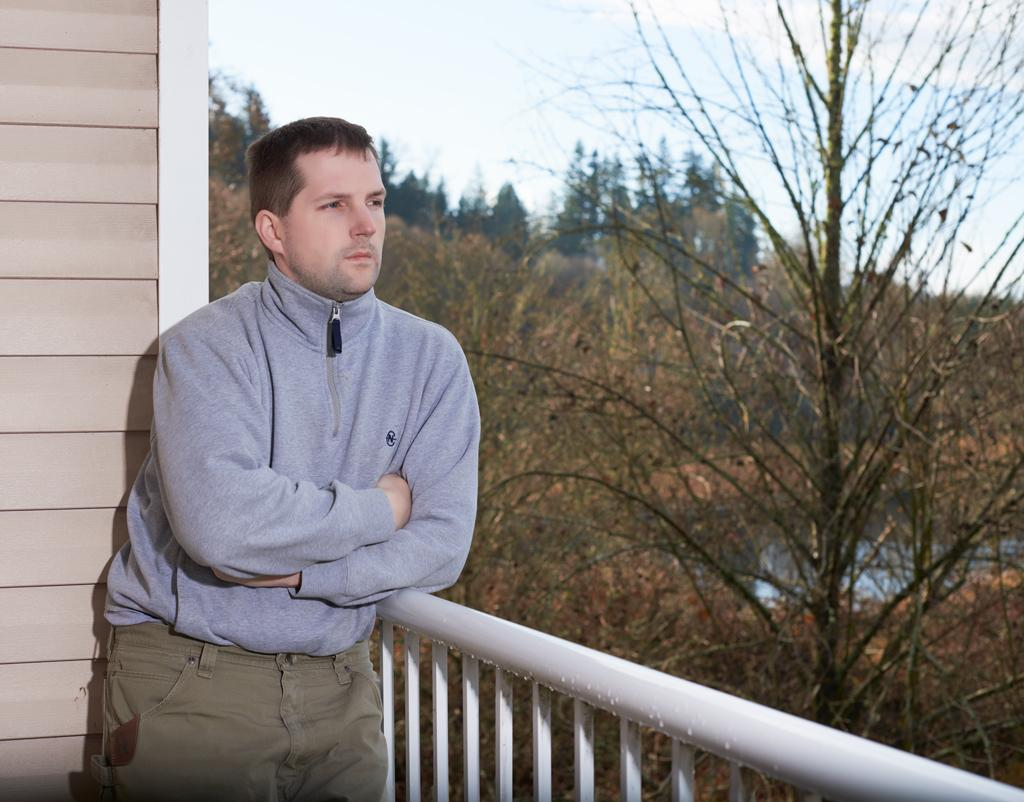What is the main subject of the image? There is a person standing in the center of the image. What structures can be seen in the image? There is a wall and a fence in the image. What can be seen in the background of the image? The sky, clouds, and trees are visible in the background of the image. What type of fork is being used by the person in the image? There is no fork present in the image; the person is not holding or using any utensils. What song is the person singing in the image? There is no indication that the person is singing in the image, and no song can be heard or seen. 